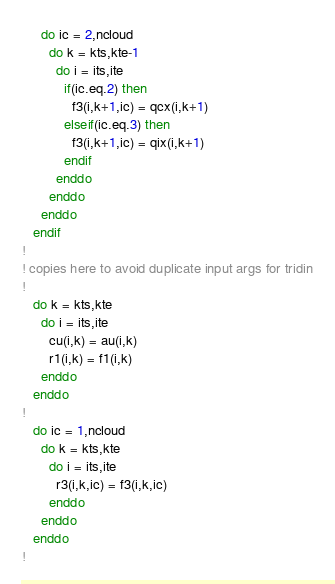<code> <loc_0><loc_0><loc_500><loc_500><_FORTRAN_>     do ic = 2,ncloud
       do k = kts,kte-1
         do i = its,ite
           if(ic.eq.2) then
             f3(i,k+1,ic) = qcx(i,k+1)
           elseif(ic.eq.3) then
             f3(i,k+1,ic) = qix(i,k+1)
           endif
         enddo
       enddo
     enddo
   endif
!
! copies here to avoid duplicate input args for tridin
!
   do k = kts,kte
     do i = its,ite
       cu(i,k) = au(i,k)
       r1(i,k) = f1(i,k)
     enddo
   enddo
!
   do ic = 1,ncloud
     do k = kts,kte
       do i = its,ite
         r3(i,k,ic) = f3(i,k,ic)
       enddo
     enddo
   enddo
!</code> 